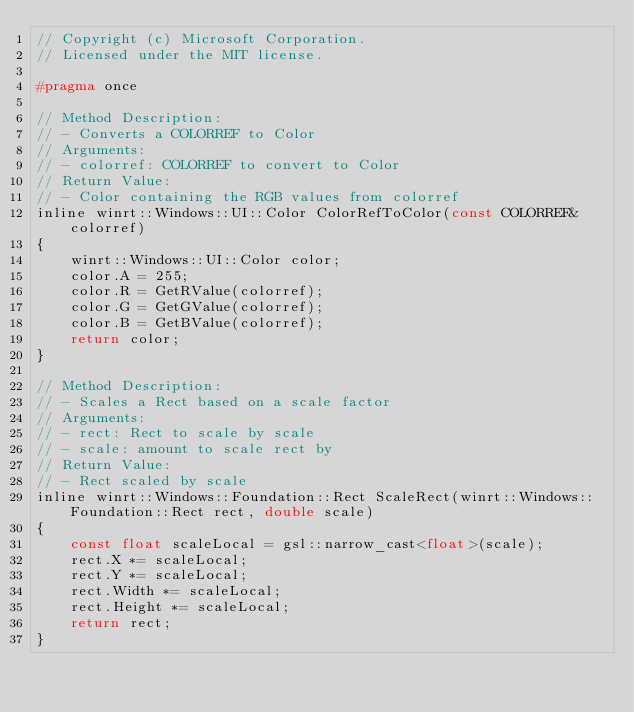<code> <loc_0><loc_0><loc_500><loc_500><_C_>// Copyright (c) Microsoft Corporation.
// Licensed under the MIT license.

#pragma once

// Method Description:
// - Converts a COLORREF to Color
// Arguments:
// - colorref: COLORREF to convert to Color
// Return Value:
// - Color containing the RGB values from colorref
inline winrt::Windows::UI::Color ColorRefToColor(const COLORREF& colorref)
{
    winrt::Windows::UI::Color color;
    color.A = 255;
    color.R = GetRValue(colorref);
    color.G = GetGValue(colorref);
    color.B = GetBValue(colorref);
    return color;
}

// Method Description:
// - Scales a Rect based on a scale factor
// Arguments:
// - rect: Rect to scale by scale
// - scale: amount to scale rect by
// Return Value:
// - Rect scaled by scale
inline winrt::Windows::Foundation::Rect ScaleRect(winrt::Windows::Foundation::Rect rect, double scale)
{
    const float scaleLocal = gsl::narrow_cast<float>(scale);
    rect.X *= scaleLocal;
    rect.Y *= scaleLocal;
    rect.Width *= scaleLocal;
    rect.Height *= scaleLocal;
    return rect;
}
</code> 